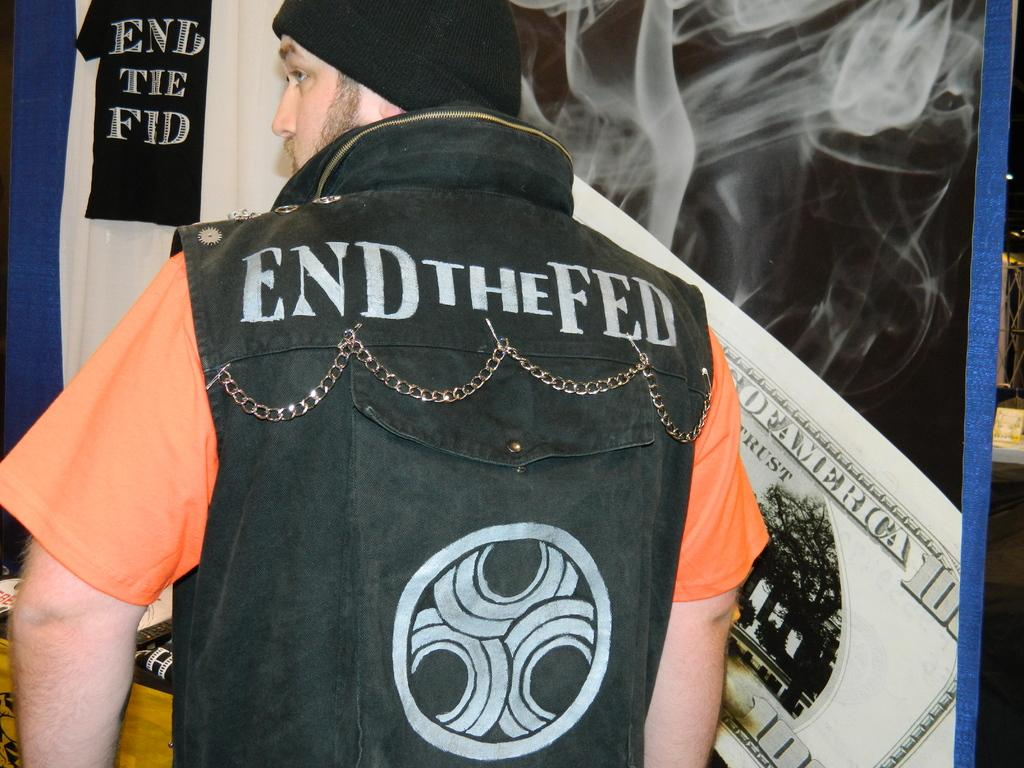<image>
Share a concise interpretation of the image provided. End the Fed is printed on the back of this vest. 